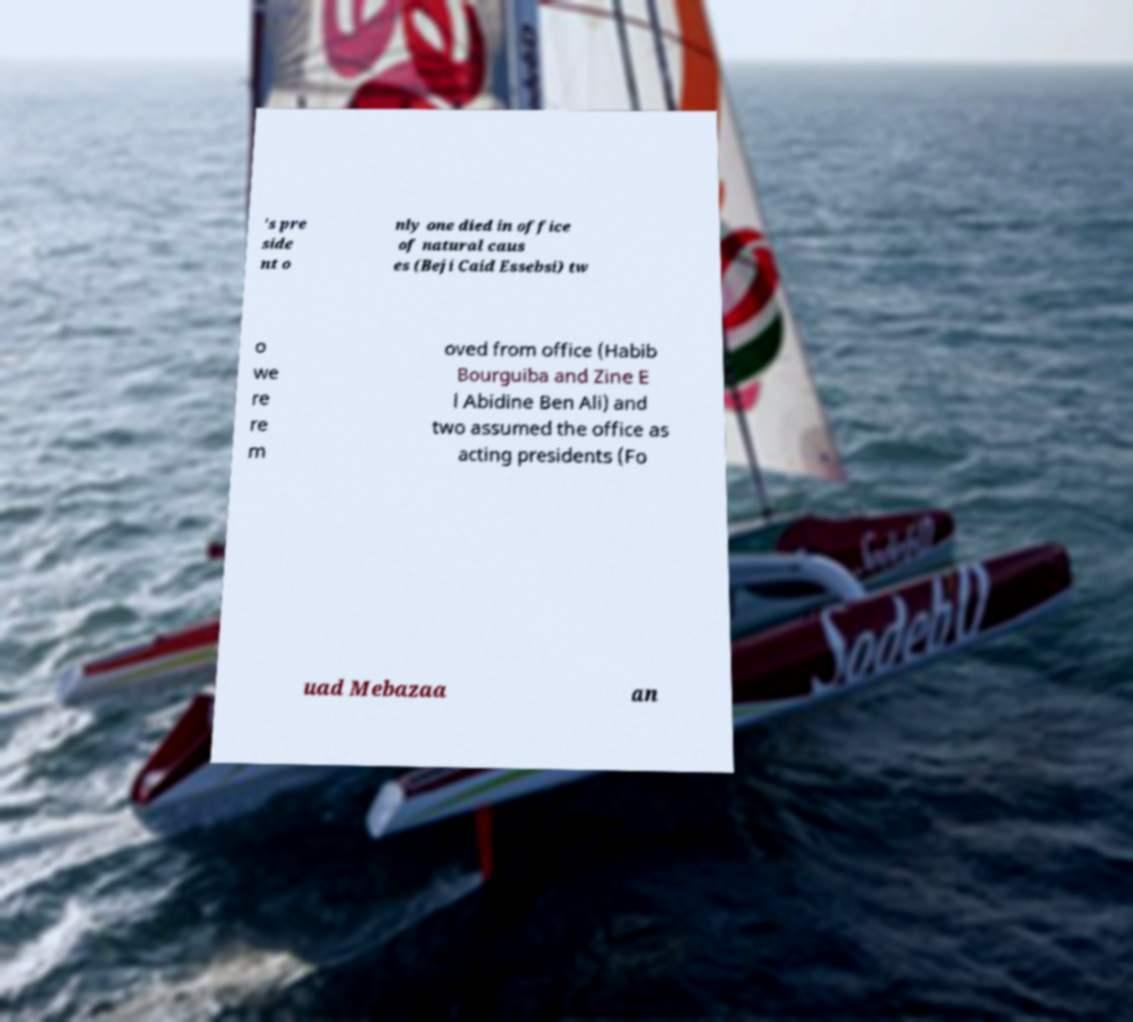Could you extract and type out the text from this image? 's pre side nt o nly one died in office of natural caus es (Beji Caid Essebsi) tw o we re re m oved from office (Habib Bourguiba and Zine E l Abidine Ben Ali) and two assumed the office as acting presidents (Fo uad Mebazaa an 